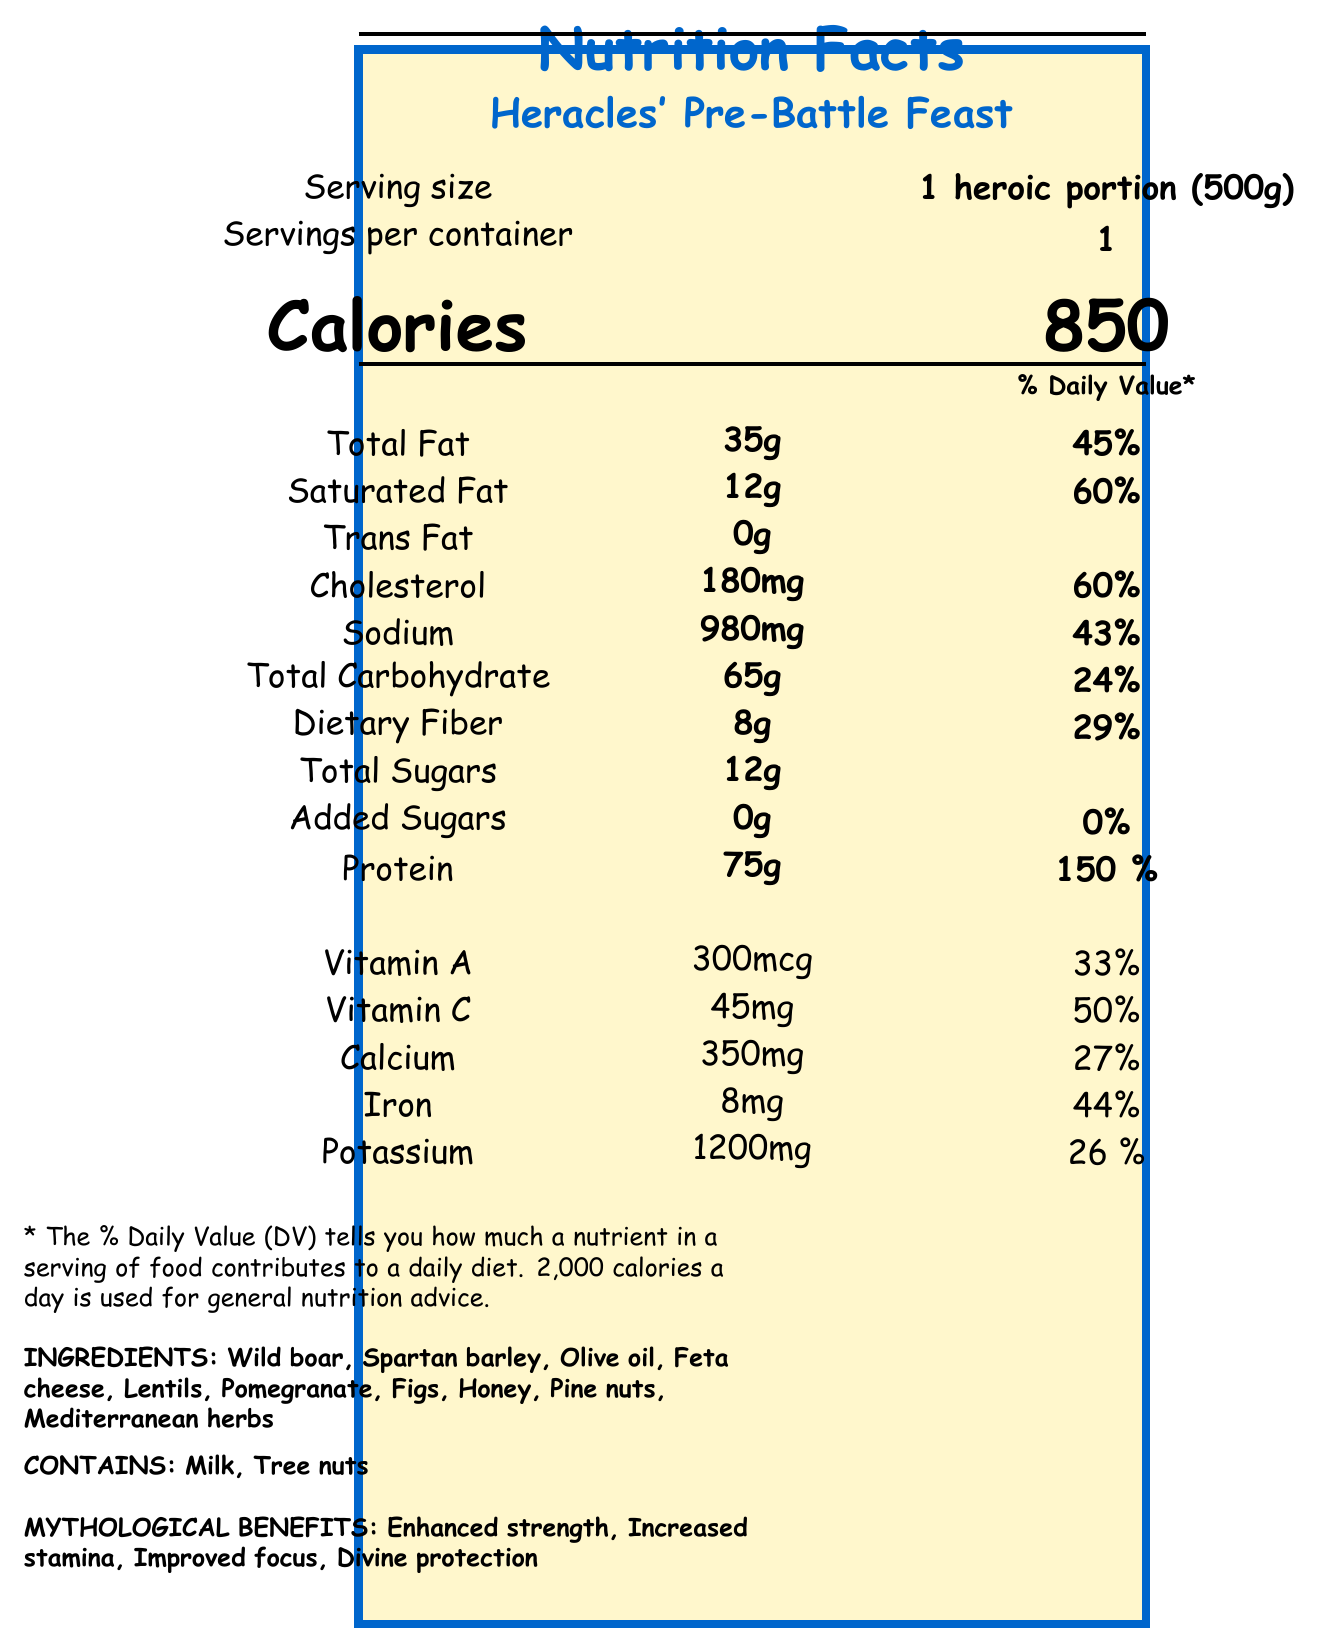what is the serving size for Heracles' Pre-Battle Feast? The serving size is clearly mentioned as "1 heroic portion (500g)" in the document.
Answer: 1 heroic portion (500g) how many calories are in one serving of the feast? The calories per serving are listed as "850" in the calorie section.
Answer: 850 calories what is the total fat content and its daily value percentage? The document states that the total fat content is 35g, which contributes to 45% of the daily value.
Answer: 35g, 45% how much protein does Heracles' meal provide and what percentage of the daily value does it cover? According to the document, the meal provides 75g of protein, covering 150% of the daily value.
Answer: 75g, 150% List two mythological benefits that the meal claims to provide. The document lists "Enhanced strength" and "Increased stamina" as mythological benefits of the meal.
Answer: Enhanced strength, Increased stamina which of the following vitamins is not mentioned in the nutrition facts? A. Vitamin A B. Vitamin B12 C. Vitamin C D. Vitamin D The document only mentions Vitamin A and Vitamin C but not Vitamin B12.
Answer: B. Vitamin B12 how much sodium is in the meal and what is its daily value percentage? A. 900mg B. 960mg C. 980mg D. 990mg The sodium content is listed as 980mg with a daily value percentage of 43%.
Answer: C. 980mg does the feast contain any trans fat? The document states that there is 0g of trans fat in the meal.
Answer: No Which of the following is not listed as an ingredient in Heracles' Pre-Battle Feast? A. Feta cheese B. Olive oil C. Lentils D. Grapes The ingredients list includes Feta cheese, Olive oil, Lentils but does not list Grapes.
Answer: D. Grapes are tree nuts present in the allergen information? The document lists "Tree nuts" as one of the allergens.
Answer: Yes summarize the main idea of the document. The document serves to inform about the composition and benefits of a mythical meal, highlighting its suitability for a hero like Heracles based on its nutritional content and legendary properties.
Answer: The document provides detailed nutritional information about Heracles' Pre-Battle Feast, a high-protein meal designed for legendary heroes preparing for battle. It lists the serving size, calorie content, nutrient breakdown, ingredients, allergens, and mythological benefits. what is the main ingredient used in Heracles' Pre-Battle Feast? The ingredients are listed but there is no indication of which one of them is the main ingredient.
Answer: Not enough information 